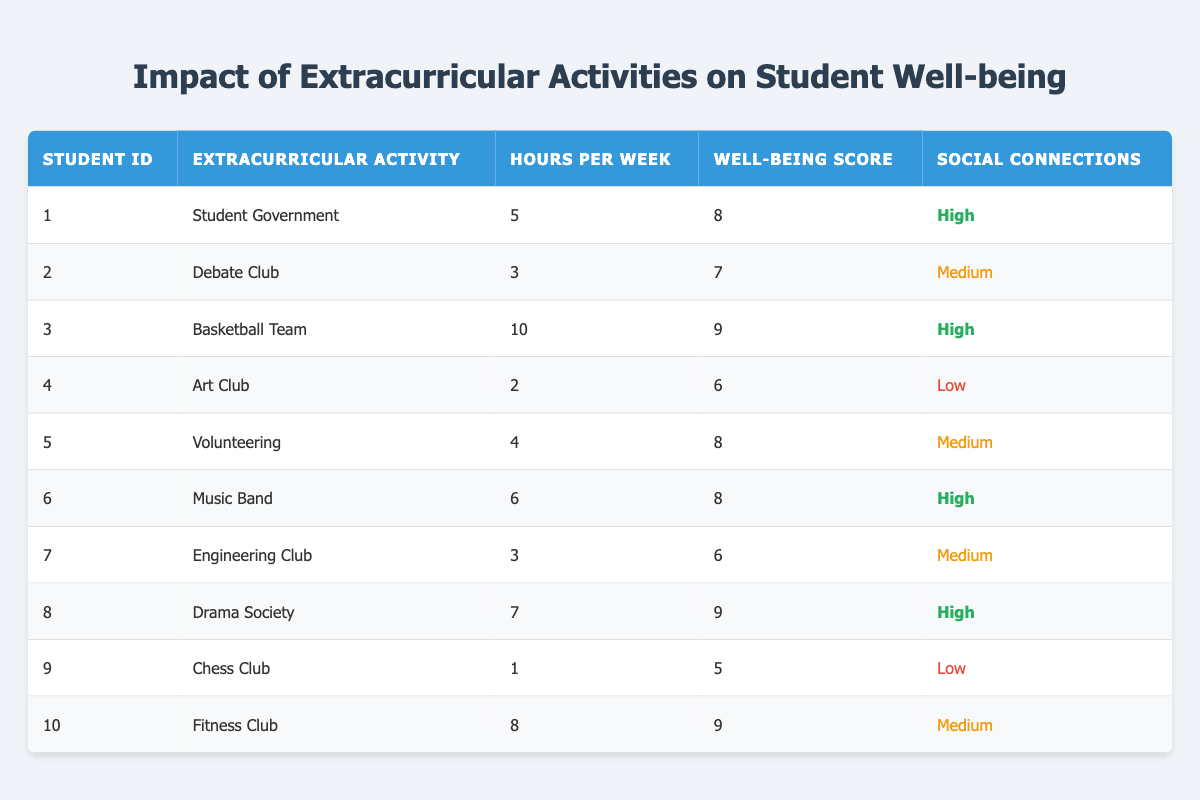What is the well-being score of the student involved in Student Government? Referring to the table, Student ID 1 participates in Student Government, and their Well-Being Score is 8.
Answer: 8 Which extracurricular activity has the highest number of hours per week? Looking at the "Hours per Week" column, the Basketball Team has the highest hours, which is 10.
Answer: Basketball Team Is there any student in the table who has a well-being score of 5? Checking the well-being scores in the table, Student ID 9, who is part of the Chess Club, has a score of 5. Therefore, the answer is yes.
Answer: Yes What is the average well-being score of students with high social connections? The students with high social connections are Student IDs 1, 3, 6, and 8, with well-being scores of 8, 9, 8, and 9, respectively. The sum is 34, and there are 4 students, so the average is 34/4 = 8.5.
Answer: 8.5 How many students have participated in extracurricular activities for more than 7 hours per week? Checking the "Hours per Week" column, the students who meet this criterion are IDs 3, 8, and 10, making a total of three students.
Answer: 3 What is the well-being score difference between students with high and low social connections? For high social connections, the scores are 8, 9, 8, and 9 (averaging to 8.5). For low social connections, the score is 5. The difference is 8.5 - 5 = 3.5.
Answer: 3.5 Is the student with the lowest well-being score involved in any extracurricular activity? Student ID 9 is involved in the Chess Club and has a well-being score of 5, indicating that yes, they are involved in an activity.
Answer: Yes Which extracurricular activity has the lowest well-being score? The Art Club has the lowest well-being score, which is 6.
Answer: Art Club How many students scored 9 on their well-being score? Looking at the Well-Being Score column, students with scores of 9 are IDs 3, 8, and 10, making a total of three students.
Answer: 3 